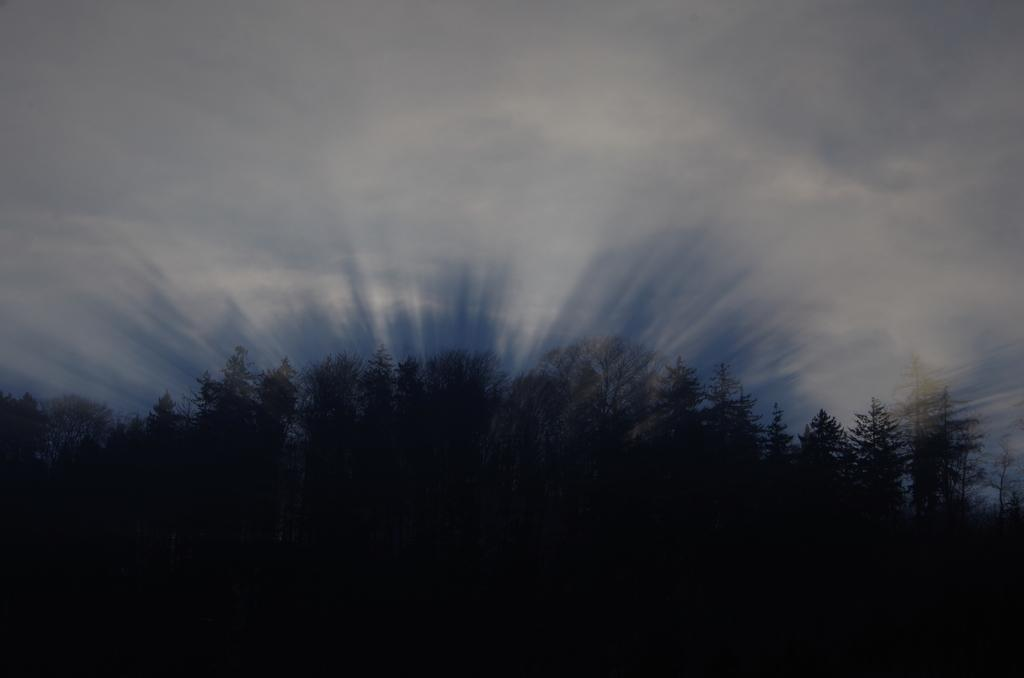What type of vegetation is visible at the bottom side of the image? There are trees at the bottom side of the image. What natural element is visible at the top side of the image? There is sky at the top side of the image. How many dogs are visible in the image? There are no dogs present in the image. What type of bun is being dropped from the sky in the image? There is no bun or any object being dropped from the sky in the image. 